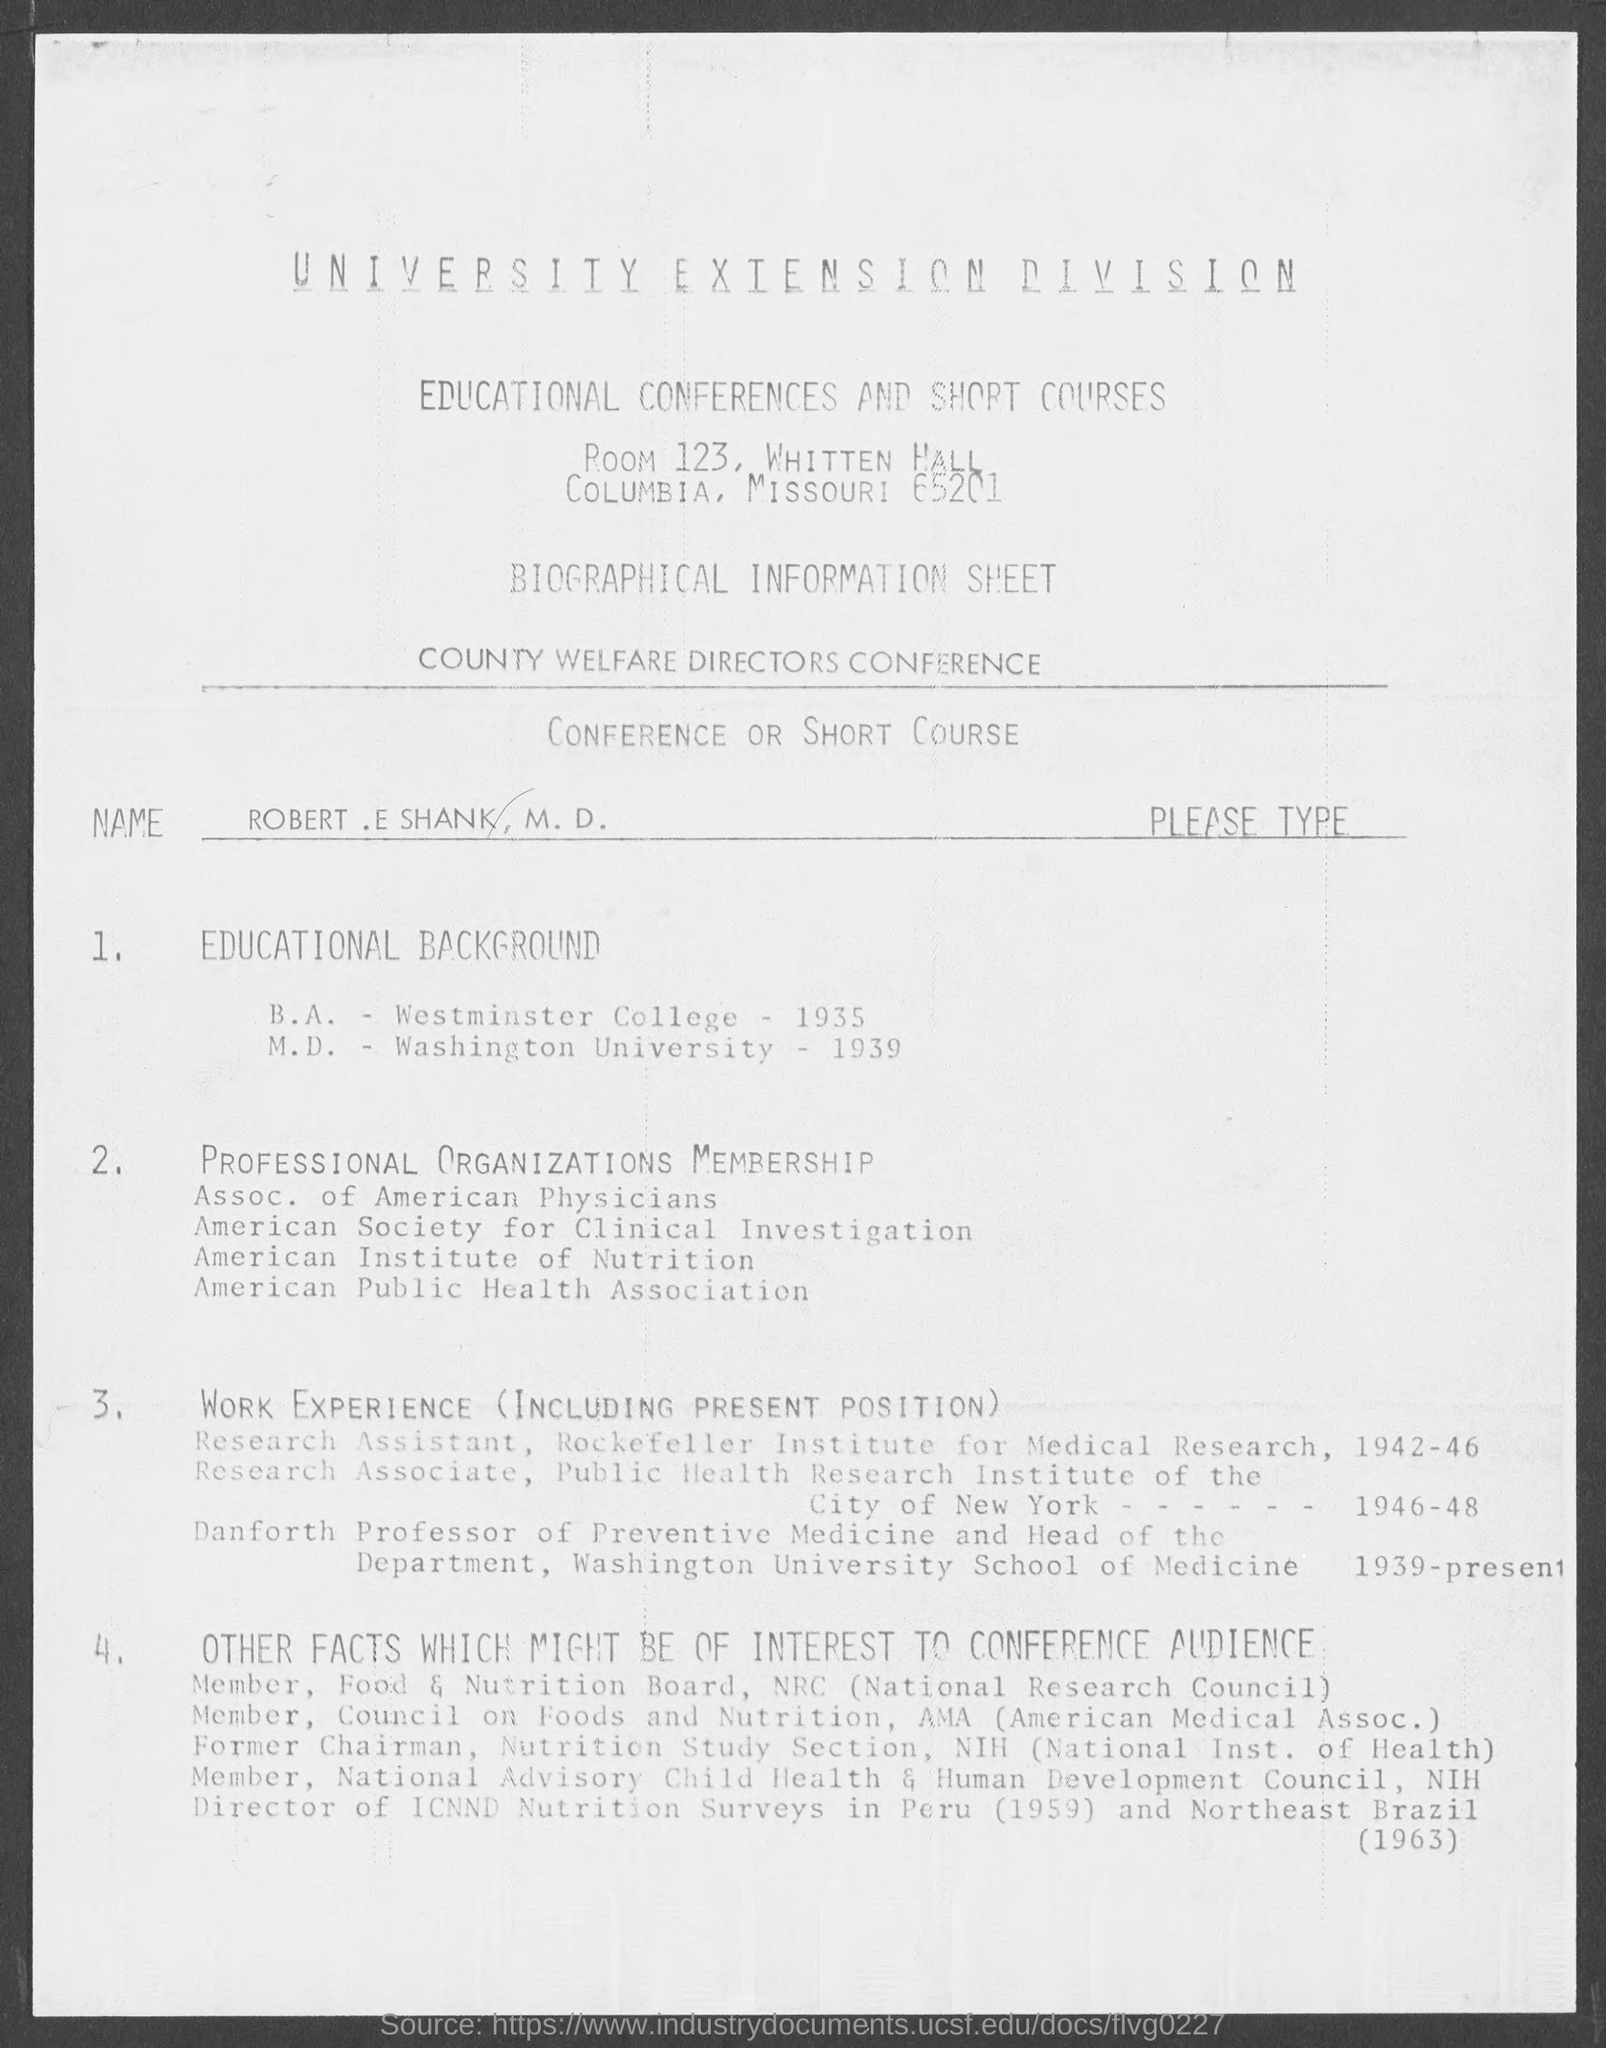In which university, Robert E. Shank completed his M.D. Degree?
Your answer should be very brief. Washington University. When did Robert E. Shank completed his B. A. degree from Westminster college?
Your response must be concise. 1935. 